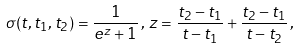<formula> <loc_0><loc_0><loc_500><loc_500>\sigma ( t , t _ { 1 } , t _ { 2 } ) = \frac { 1 } { e ^ { z } + 1 } \, , \, z = \frac { t _ { 2 } - t _ { 1 } } { t - t _ { 1 } } + \frac { t _ { 2 } - t _ { 1 } } { t - t _ { 2 } } \, ,</formula> 